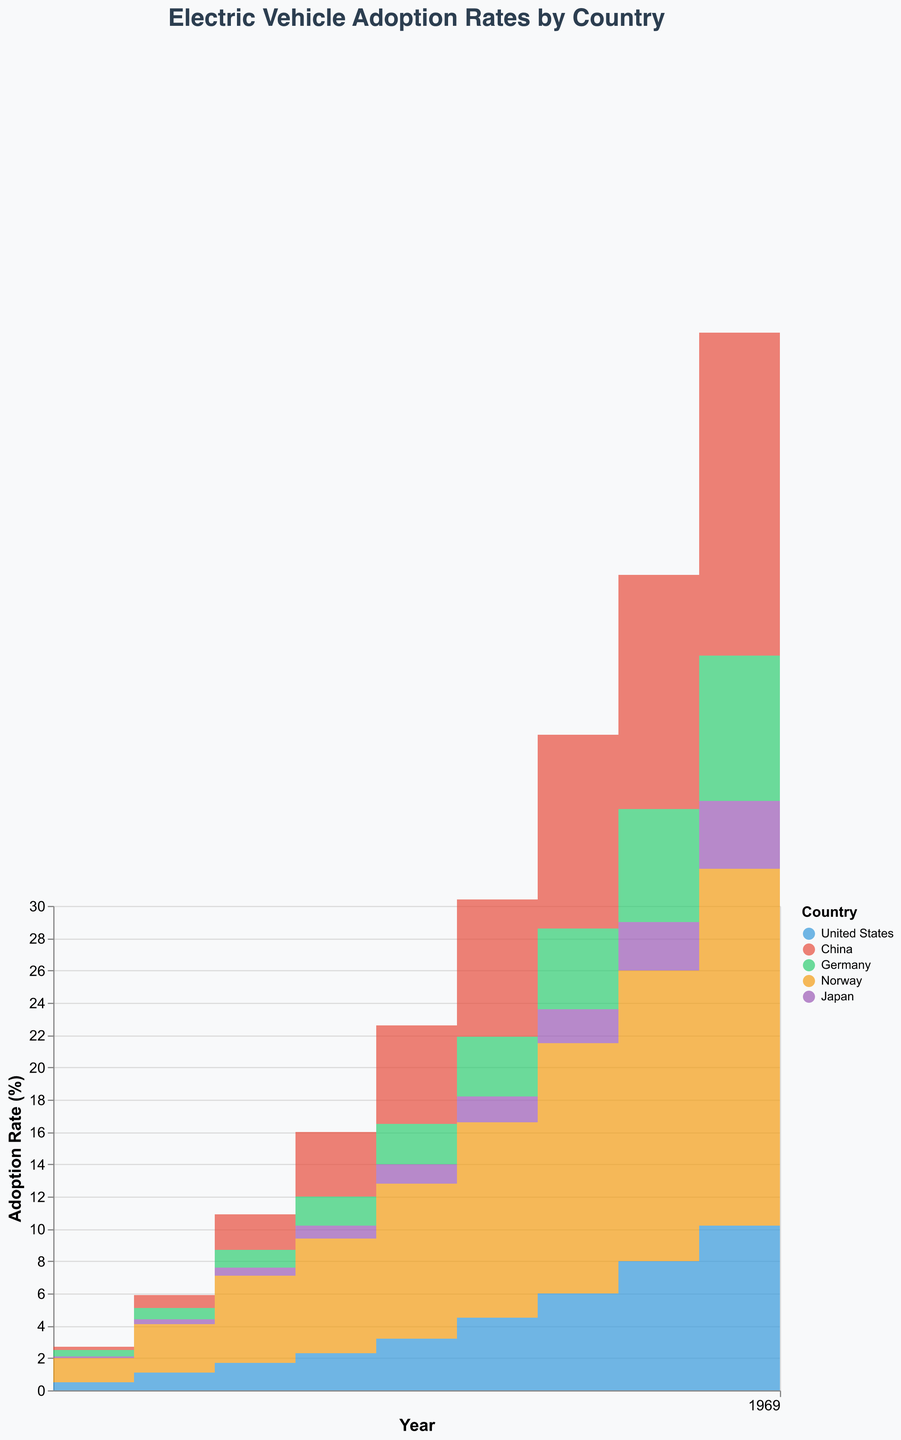What country had the highest electric vehicle adoption rate in 2022? Look for the country with the highest value on the Adoption Rate axis in 2022.
Answer: China Which country had the lowest adoption rate in 2013? Identify the lowest value on the Adoption Rate axis for the year 2013 and the corresponding country.
Answer: Japan How did the adoption rate for electric vehicles in Norway change from 2013 to 2016? Examine the values for Norway in 2013 and 2016 and calculate the difference: 7.1 - 1.5
Answer: An increase of 5.6% Which country's adoption rate surpassed 20% first, and in what year? Locate the first instance where a country's adoption rate exceeds 20% and note the country and year.
Answer: China in 2021 Compare the adoption rate growth between Germany and Japan from 2019 to 2022. For Germany: 12.8 - 5.0 = 7.8, for Japan: 6.5 - 2.1 = 4.4. Compare the differences.
Answer: Germany's growth is 7.8%, Japan's growth is 4.4% What is the range of adoption rates for the United States over the decade? Identify the minimum and maximum values in the Adoption Rate axis for the United States from 2013 to 2022. Range is 15.2 - 0.5
Answer: The range is 14.7% Which two countries had the closest adoption rates in 2022? Compare the 2022 adoption rates and find the pair with the smallest difference.
Answer: Norway and China What is the average adoption rate growth per year for China from 2013 to 2022? Sum the differences in adoption rate from year to year and divide by the number of years: (0.8-0.2 + 2.2-0.8 + ... + 25.1-20.0) / 9
Answer: Approximately 2.77% per year At what year did Germany's adoption rate reach 5%? Check the values on the Adoption Rate axis for Germany and see when it first reaches or exceeds 5%.
Answer: 2019 